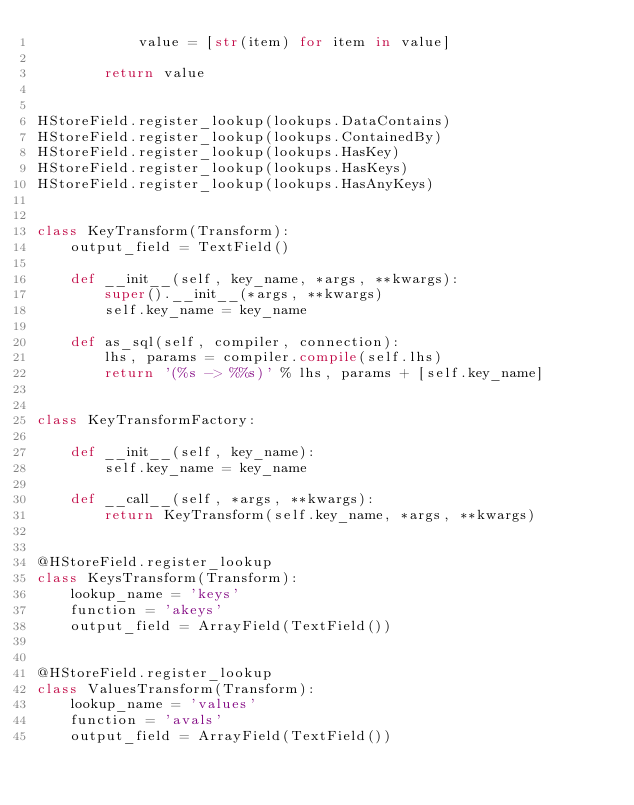<code> <loc_0><loc_0><loc_500><loc_500><_Python_>            value = [str(item) for item in value]

        return value


HStoreField.register_lookup(lookups.DataContains)
HStoreField.register_lookup(lookups.ContainedBy)
HStoreField.register_lookup(lookups.HasKey)
HStoreField.register_lookup(lookups.HasKeys)
HStoreField.register_lookup(lookups.HasAnyKeys)


class KeyTransform(Transform):
    output_field = TextField()

    def __init__(self, key_name, *args, **kwargs):
        super().__init__(*args, **kwargs)
        self.key_name = key_name

    def as_sql(self, compiler, connection):
        lhs, params = compiler.compile(self.lhs)
        return '(%s -> %%s)' % lhs, params + [self.key_name]


class KeyTransformFactory:

    def __init__(self, key_name):
        self.key_name = key_name

    def __call__(self, *args, **kwargs):
        return KeyTransform(self.key_name, *args, **kwargs)


@HStoreField.register_lookup
class KeysTransform(Transform):
    lookup_name = 'keys'
    function = 'akeys'
    output_field = ArrayField(TextField())


@HStoreField.register_lookup
class ValuesTransform(Transform):
    lookup_name = 'values'
    function = 'avals'
    output_field = ArrayField(TextField())
</code> 